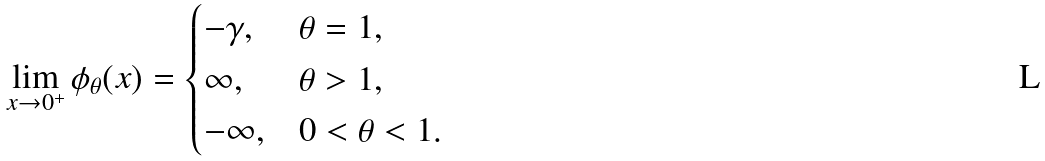<formula> <loc_0><loc_0><loc_500><loc_500>\lim _ { x \to 0 ^ { + } } \phi _ { \theta } ( x ) = \begin{cases} - \gamma , & \theta = 1 , \\ \infty , & \theta > 1 , \\ - \infty , & 0 < \theta < 1 . \end{cases}</formula> 